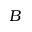<formula> <loc_0><loc_0><loc_500><loc_500>B</formula> 